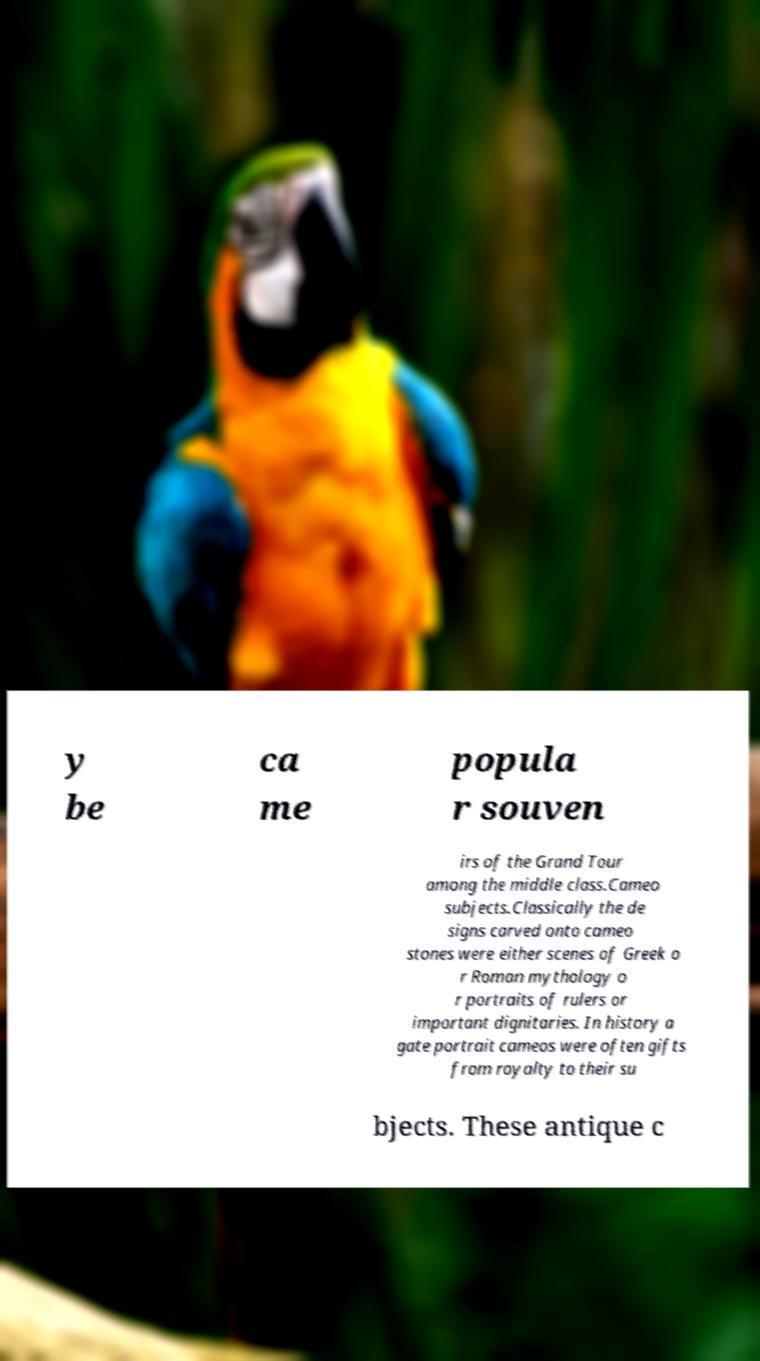Please identify and transcribe the text found in this image. y be ca me popula r souven irs of the Grand Tour among the middle class.Cameo subjects.Classically the de signs carved onto cameo stones were either scenes of Greek o r Roman mythology o r portraits of rulers or important dignitaries. In history a gate portrait cameos were often gifts from royalty to their su bjects. These antique c 